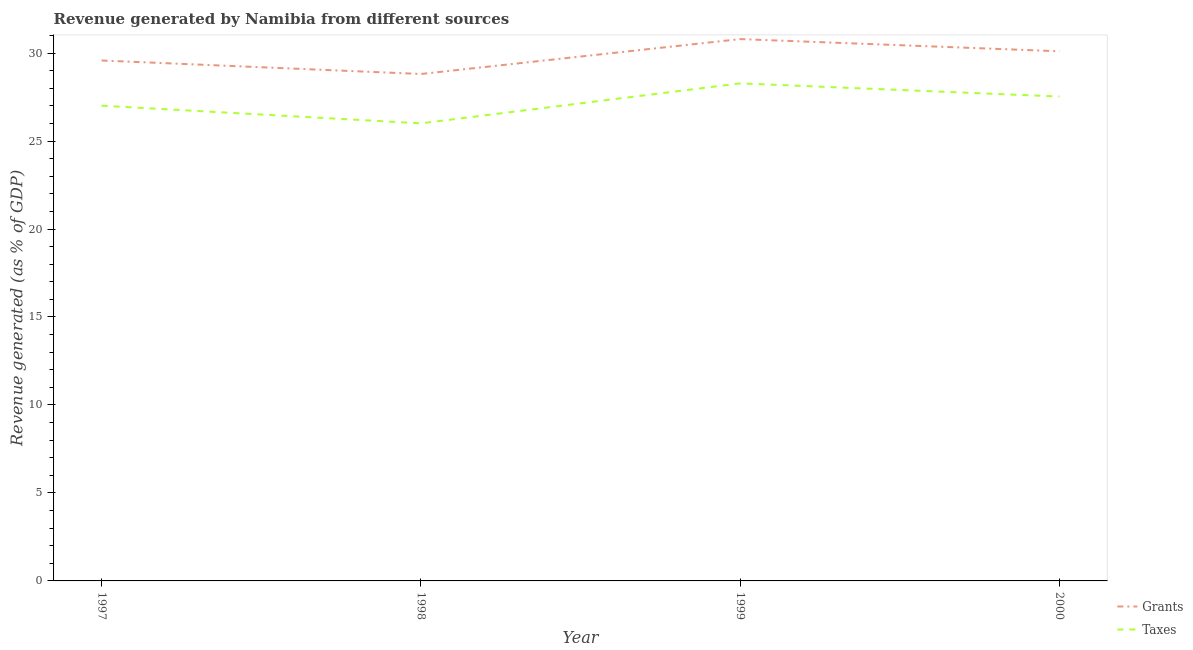What is the revenue generated by grants in 1997?
Offer a terse response. 29.58. Across all years, what is the maximum revenue generated by taxes?
Provide a succinct answer. 28.28. Across all years, what is the minimum revenue generated by taxes?
Keep it short and to the point. 26.01. In which year was the revenue generated by taxes minimum?
Give a very brief answer. 1998. What is the total revenue generated by taxes in the graph?
Your answer should be compact. 108.82. What is the difference between the revenue generated by grants in 1997 and that in 2000?
Your answer should be compact. -0.52. What is the difference between the revenue generated by taxes in 1997 and the revenue generated by grants in 2000?
Give a very brief answer. -3.09. What is the average revenue generated by taxes per year?
Give a very brief answer. 27.21. In the year 1998, what is the difference between the revenue generated by taxes and revenue generated by grants?
Provide a succinct answer. -2.8. What is the ratio of the revenue generated by grants in 1999 to that in 2000?
Your response must be concise. 1.02. Is the revenue generated by taxes in 1997 less than that in 1999?
Offer a terse response. Yes. Is the difference between the revenue generated by grants in 1997 and 1998 greater than the difference between the revenue generated by taxes in 1997 and 1998?
Ensure brevity in your answer.  No. What is the difference between the highest and the second highest revenue generated by grants?
Offer a very short reply. 0.69. What is the difference between the highest and the lowest revenue generated by taxes?
Offer a very short reply. 2.27. Is the sum of the revenue generated by taxes in 1997 and 1999 greater than the maximum revenue generated by grants across all years?
Give a very brief answer. Yes. Does the revenue generated by taxes monotonically increase over the years?
Your response must be concise. No. What is the difference between two consecutive major ticks on the Y-axis?
Give a very brief answer. 5. Are the values on the major ticks of Y-axis written in scientific E-notation?
Ensure brevity in your answer.  No. Does the graph contain grids?
Provide a succinct answer. No. Where does the legend appear in the graph?
Keep it short and to the point. Bottom right. How many legend labels are there?
Offer a terse response. 2. How are the legend labels stacked?
Give a very brief answer. Vertical. What is the title of the graph?
Your answer should be very brief. Revenue generated by Namibia from different sources. Does "IMF concessional" appear as one of the legend labels in the graph?
Offer a very short reply. No. What is the label or title of the Y-axis?
Give a very brief answer. Revenue generated (as % of GDP). What is the Revenue generated (as % of GDP) in Grants in 1997?
Provide a succinct answer. 29.58. What is the Revenue generated (as % of GDP) of Taxes in 1997?
Your answer should be very brief. 27.01. What is the Revenue generated (as % of GDP) of Grants in 1998?
Your answer should be very brief. 28.81. What is the Revenue generated (as % of GDP) in Taxes in 1998?
Offer a very short reply. 26.01. What is the Revenue generated (as % of GDP) in Grants in 1999?
Provide a succinct answer. 30.79. What is the Revenue generated (as % of GDP) in Taxes in 1999?
Your answer should be very brief. 28.28. What is the Revenue generated (as % of GDP) of Grants in 2000?
Keep it short and to the point. 30.1. What is the Revenue generated (as % of GDP) of Taxes in 2000?
Your answer should be very brief. 27.53. Across all years, what is the maximum Revenue generated (as % of GDP) of Grants?
Ensure brevity in your answer.  30.79. Across all years, what is the maximum Revenue generated (as % of GDP) of Taxes?
Give a very brief answer. 28.28. Across all years, what is the minimum Revenue generated (as % of GDP) in Grants?
Your response must be concise. 28.81. Across all years, what is the minimum Revenue generated (as % of GDP) of Taxes?
Your answer should be compact. 26.01. What is the total Revenue generated (as % of GDP) in Grants in the graph?
Your response must be concise. 119.28. What is the total Revenue generated (as % of GDP) of Taxes in the graph?
Give a very brief answer. 108.82. What is the difference between the Revenue generated (as % of GDP) in Grants in 1997 and that in 1998?
Keep it short and to the point. 0.77. What is the difference between the Revenue generated (as % of GDP) of Taxes in 1997 and that in 1998?
Provide a succinct answer. 1. What is the difference between the Revenue generated (as % of GDP) in Grants in 1997 and that in 1999?
Give a very brief answer. -1.22. What is the difference between the Revenue generated (as % of GDP) in Taxes in 1997 and that in 1999?
Keep it short and to the point. -1.27. What is the difference between the Revenue generated (as % of GDP) of Grants in 1997 and that in 2000?
Ensure brevity in your answer.  -0.52. What is the difference between the Revenue generated (as % of GDP) of Taxes in 1997 and that in 2000?
Keep it short and to the point. -0.52. What is the difference between the Revenue generated (as % of GDP) of Grants in 1998 and that in 1999?
Give a very brief answer. -1.98. What is the difference between the Revenue generated (as % of GDP) of Taxes in 1998 and that in 1999?
Offer a very short reply. -2.27. What is the difference between the Revenue generated (as % of GDP) in Grants in 1998 and that in 2000?
Keep it short and to the point. -1.29. What is the difference between the Revenue generated (as % of GDP) in Taxes in 1998 and that in 2000?
Give a very brief answer. -1.52. What is the difference between the Revenue generated (as % of GDP) in Grants in 1999 and that in 2000?
Ensure brevity in your answer.  0.69. What is the difference between the Revenue generated (as % of GDP) of Taxes in 1999 and that in 2000?
Offer a terse response. 0.75. What is the difference between the Revenue generated (as % of GDP) in Grants in 1997 and the Revenue generated (as % of GDP) in Taxes in 1998?
Your response must be concise. 3.57. What is the difference between the Revenue generated (as % of GDP) of Grants in 1997 and the Revenue generated (as % of GDP) of Taxes in 1999?
Your answer should be very brief. 1.3. What is the difference between the Revenue generated (as % of GDP) of Grants in 1997 and the Revenue generated (as % of GDP) of Taxes in 2000?
Ensure brevity in your answer.  2.05. What is the difference between the Revenue generated (as % of GDP) of Grants in 1998 and the Revenue generated (as % of GDP) of Taxes in 1999?
Ensure brevity in your answer.  0.53. What is the difference between the Revenue generated (as % of GDP) of Grants in 1998 and the Revenue generated (as % of GDP) of Taxes in 2000?
Your response must be concise. 1.28. What is the difference between the Revenue generated (as % of GDP) in Grants in 1999 and the Revenue generated (as % of GDP) in Taxes in 2000?
Provide a short and direct response. 3.27. What is the average Revenue generated (as % of GDP) in Grants per year?
Offer a terse response. 29.82. What is the average Revenue generated (as % of GDP) of Taxes per year?
Provide a short and direct response. 27.21. In the year 1997, what is the difference between the Revenue generated (as % of GDP) in Grants and Revenue generated (as % of GDP) in Taxes?
Provide a succinct answer. 2.57. In the year 1998, what is the difference between the Revenue generated (as % of GDP) of Grants and Revenue generated (as % of GDP) of Taxes?
Offer a very short reply. 2.8. In the year 1999, what is the difference between the Revenue generated (as % of GDP) in Grants and Revenue generated (as % of GDP) in Taxes?
Make the answer very short. 2.52. In the year 2000, what is the difference between the Revenue generated (as % of GDP) in Grants and Revenue generated (as % of GDP) in Taxes?
Offer a very short reply. 2.57. What is the ratio of the Revenue generated (as % of GDP) of Grants in 1997 to that in 1998?
Offer a terse response. 1.03. What is the ratio of the Revenue generated (as % of GDP) of Grants in 1997 to that in 1999?
Your answer should be very brief. 0.96. What is the ratio of the Revenue generated (as % of GDP) of Taxes in 1997 to that in 1999?
Ensure brevity in your answer.  0.96. What is the ratio of the Revenue generated (as % of GDP) in Grants in 1997 to that in 2000?
Your answer should be very brief. 0.98. What is the ratio of the Revenue generated (as % of GDP) of Taxes in 1997 to that in 2000?
Your answer should be compact. 0.98. What is the ratio of the Revenue generated (as % of GDP) of Grants in 1998 to that in 1999?
Keep it short and to the point. 0.94. What is the ratio of the Revenue generated (as % of GDP) of Taxes in 1998 to that in 1999?
Your response must be concise. 0.92. What is the ratio of the Revenue generated (as % of GDP) of Grants in 1998 to that in 2000?
Offer a terse response. 0.96. What is the ratio of the Revenue generated (as % of GDP) of Taxes in 1998 to that in 2000?
Provide a short and direct response. 0.94. What is the ratio of the Revenue generated (as % of GDP) of Grants in 1999 to that in 2000?
Provide a succinct answer. 1.02. What is the ratio of the Revenue generated (as % of GDP) in Taxes in 1999 to that in 2000?
Give a very brief answer. 1.03. What is the difference between the highest and the second highest Revenue generated (as % of GDP) in Grants?
Offer a very short reply. 0.69. What is the difference between the highest and the second highest Revenue generated (as % of GDP) in Taxes?
Make the answer very short. 0.75. What is the difference between the highest and the lowest Revenue generated (as % of GDP) in Grants?
Your answer should be very brief. 1.98. What is the difference between the highest and the lowest Revenue generated (as % of GDP) in Taxes?
Offer a very short reply. 2.27. 